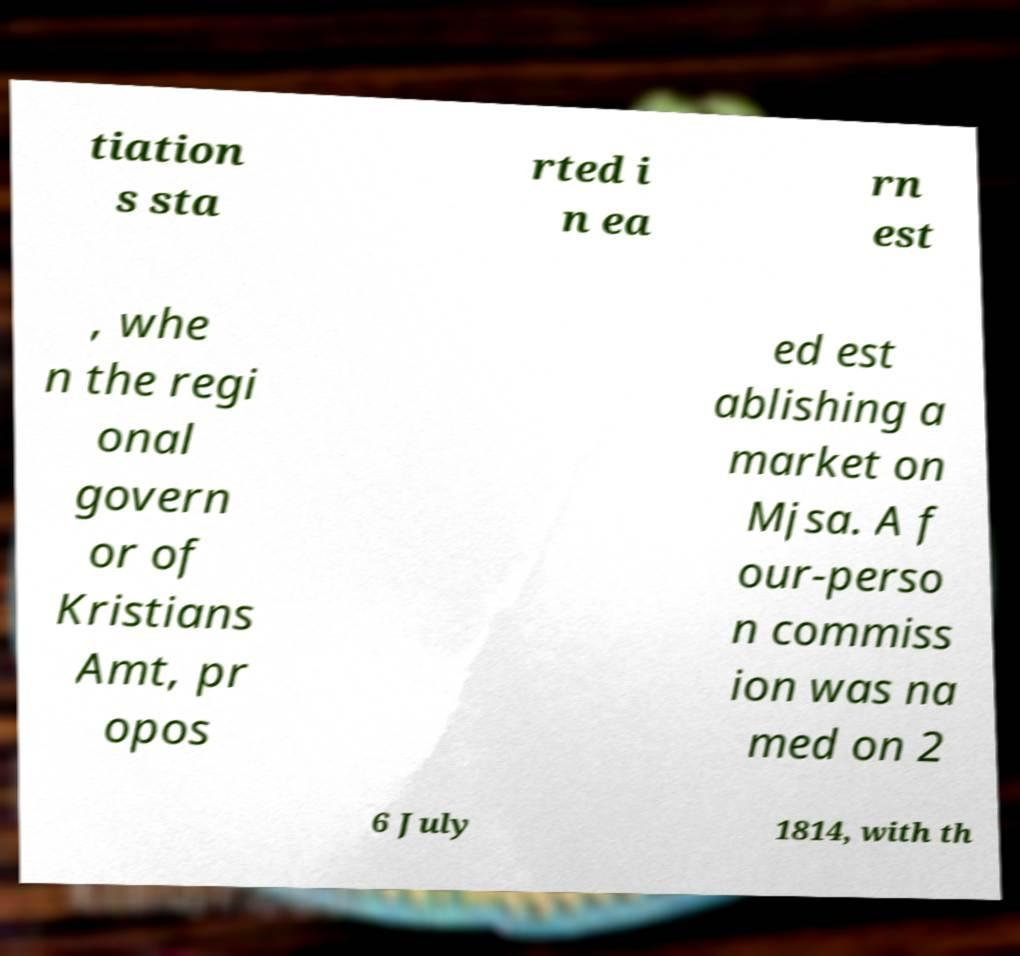What messages or text are displayed in this image? I need them in a readable, typed format. tiation s sta rted i n ea rn est , whe n the regi onal govern or of Kristians Amt, pr opos ed est ablishing a market on Mjsa. A f our-perso n commiss ion was na med on 2 6 July 1814, with th 